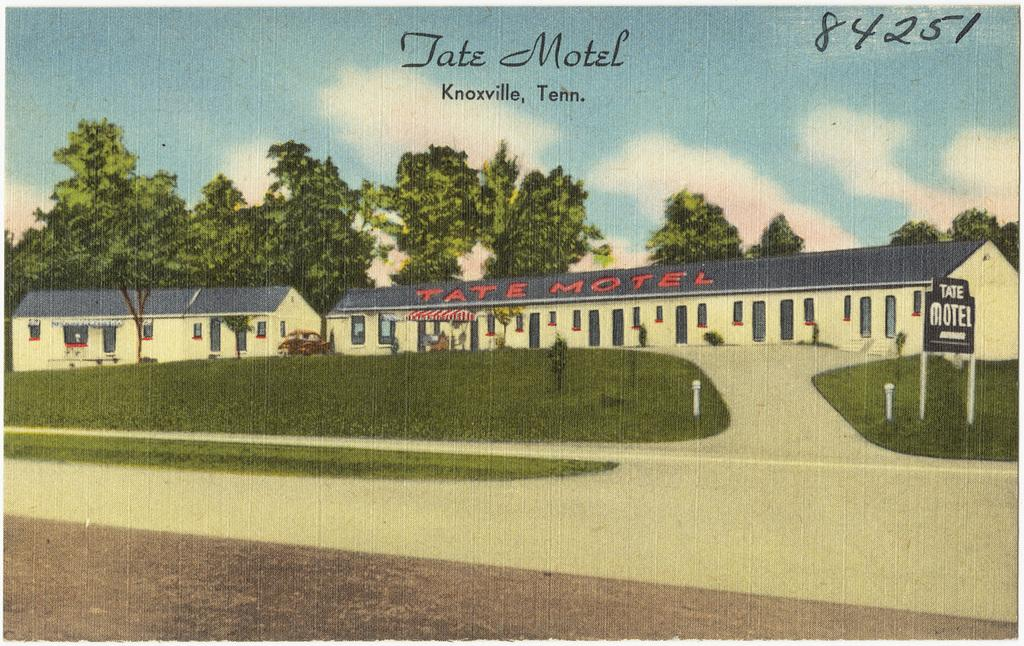What type of buildings can be seen in the image? There are hotels in the image. What type of vegetation is present in the image? There is grass, plants, and trees in the image. What is the border in the image used for? The border in the image is used to separate different elements or areas. What is the vehicle in the image? There is a vehicle in the image, but its specific type is not mentioned. What is visible in the background of the image? The sky is visible in the background of the image, with clouds present. Are there any watermarks in the image? Yes, there are watermarks in the image. What type of salt is being used to season the plants in the image? There is no salt present in the image, nor is there any indication that the plants are being seasoned. What type of authority is depicted in the image? There is no authority figure or representation of authority present in the image. 